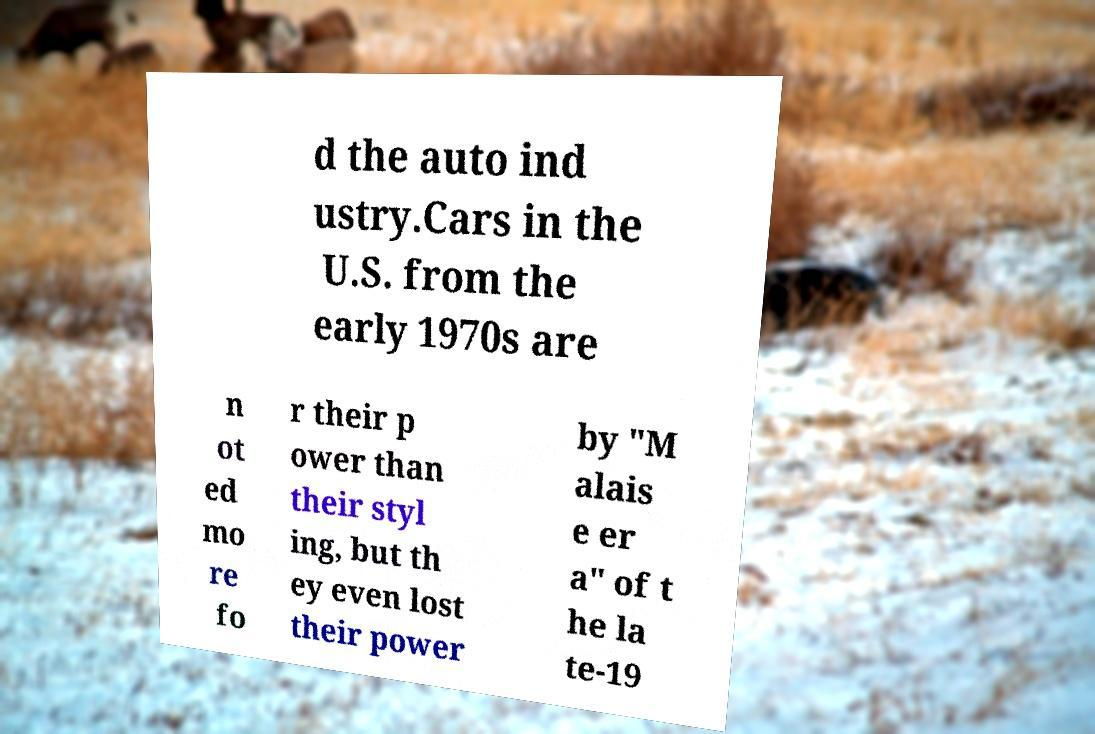Could you extract and type out the text from this image? d the auto ind ustry.Cars in the U.S. from the early 1970s are n ot ed mo re fo r their p ower than their styl ing, but th ey even lost their power by "M alais e er a" of t he la te-19 